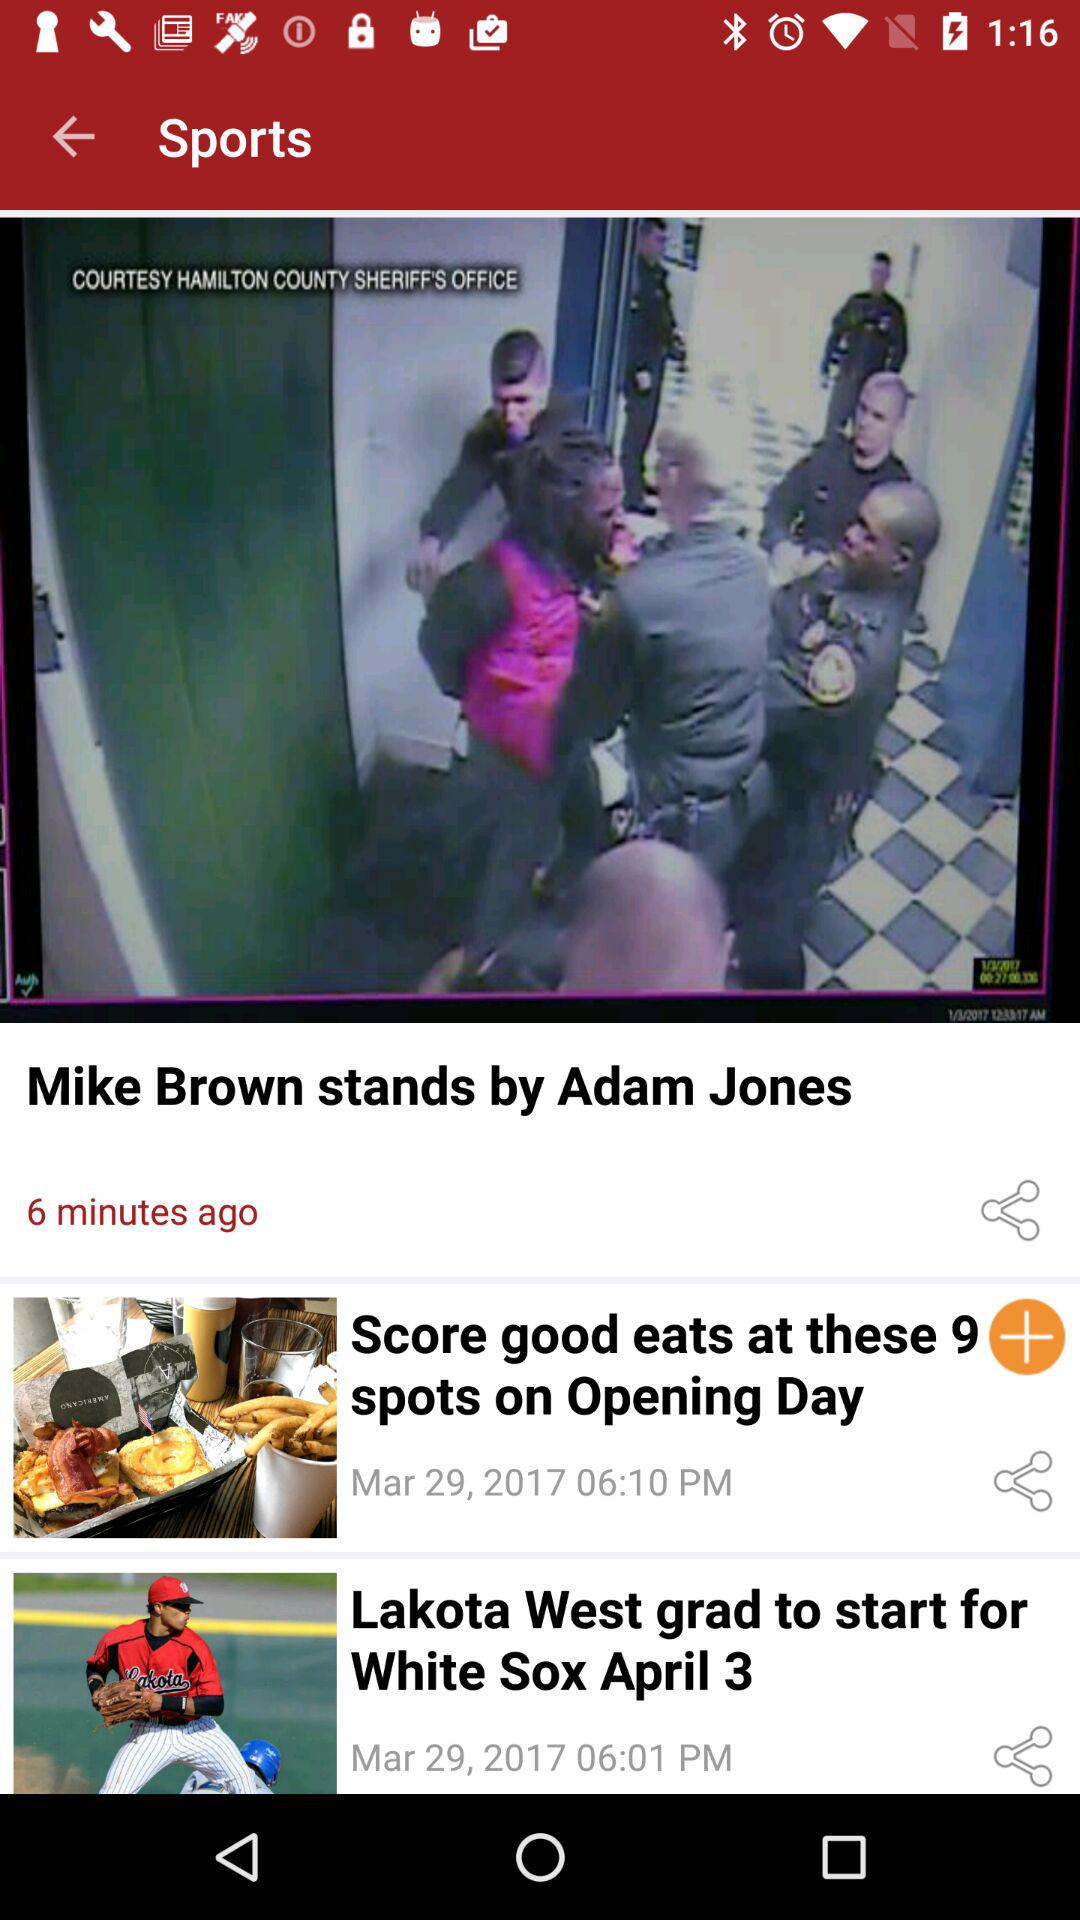What is the publication date of the article "Score good eats at these 9 spots on Opening Day"? The publication date of the article is March 29, 2017. 